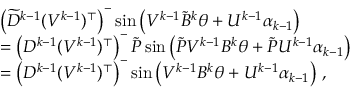Convert formula to latex. <formula><loc_0><loc_0><loc_500><loc_500>\begin{array} { r l } & { \left ( \widetilde { D } ^ { k - 1 } ( V ^ { k - 1 } ) ^ { \top } \right ) ^ { - } \sin \left ( V ^ { k - 1 } \widetilde { B } ^ { k } \theta + U ^ { k - 1 } \alpha _ { k - 1 } \right ) } \\ & { = \left ( D ^ { k - 1 } ( V ^ { k - 1 } ) ^ { \top } \right ) ^ { - } \widetilde { P } \sin \left ( \widetilde { P } V ^ { k - 1 } B ^ { k } \theta + \widetilde { P } U ^ { k - 1 } \alpha _ { k - 1 } \right ) } \\ & { = \left ( D ^ { k - 1 } ( V ^ { k - 1 } ) ^ { \top } \right ) ^ { - } \sin \left ( V ^ { k - 1 } B ^ { k } \theta + U ^ { k - 1 } \alpha _ { k - 1 } \right ) \, , } \end{array}</formula> 